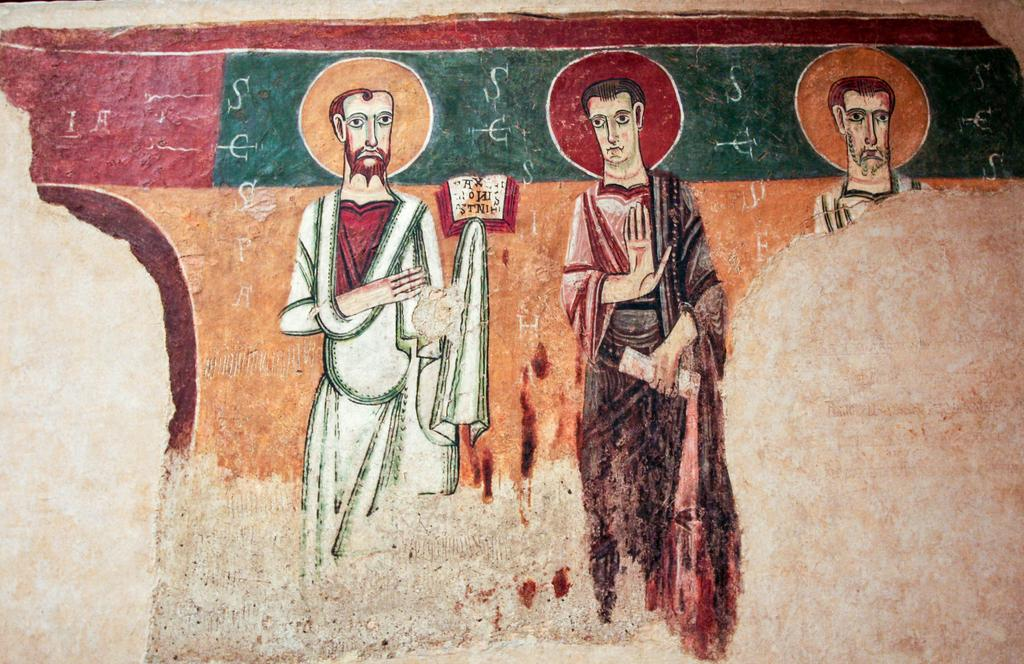What is on the wall in the image? There is a painting on the wall in the image. What does the painting depict? The painting depicts people. How would you describe the appearance of the painting? The painting contains many colors. What type of liquid can be seen flowing from the doll's eyes in the image? There is no doll or liquid present in the image; it only features a painting on the wall. 